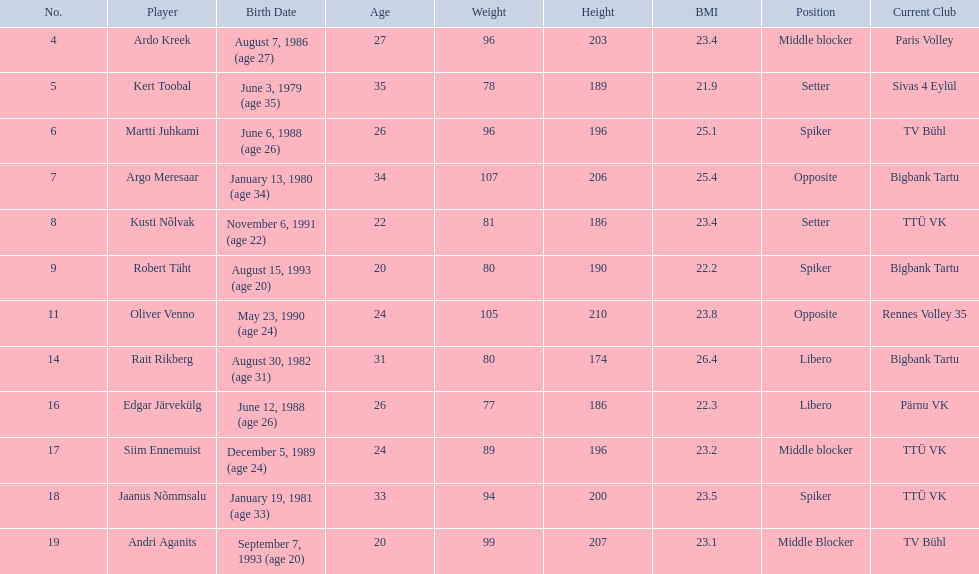What are the total number of players from france? 2. 